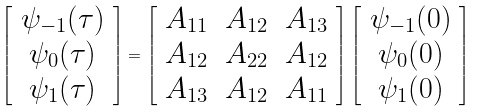<formula> <loc_0><loc_0><loc_500><loc_500>\left [ \begin{array} { c } \psi _ { - 1 } ( \tau ) \\ \psi _ { 0 } ( \tau ) \\ \psi _ { 1 } ( \tau ) \end{array} \right ] = \left [ \begin{array} { c c c } A _ { 1 1 } & A _ { 1 2 } & A _ { 1 3 } \\ A _ { 1 2 } & A _ { 2 2 } & A _ { 1 2 } \\ A _ { 1 3 } & A _ { 1 2 } & A _ { 1 1 } \end{array} \right ] \left [ \begin{array} { c } \psi _ { - 1 } ( 0 ) \\ \psi _ { 0 } ( 0 ) \\ \psi _ { 1 } ( 0 ) \end{array} \right ]</formula> 